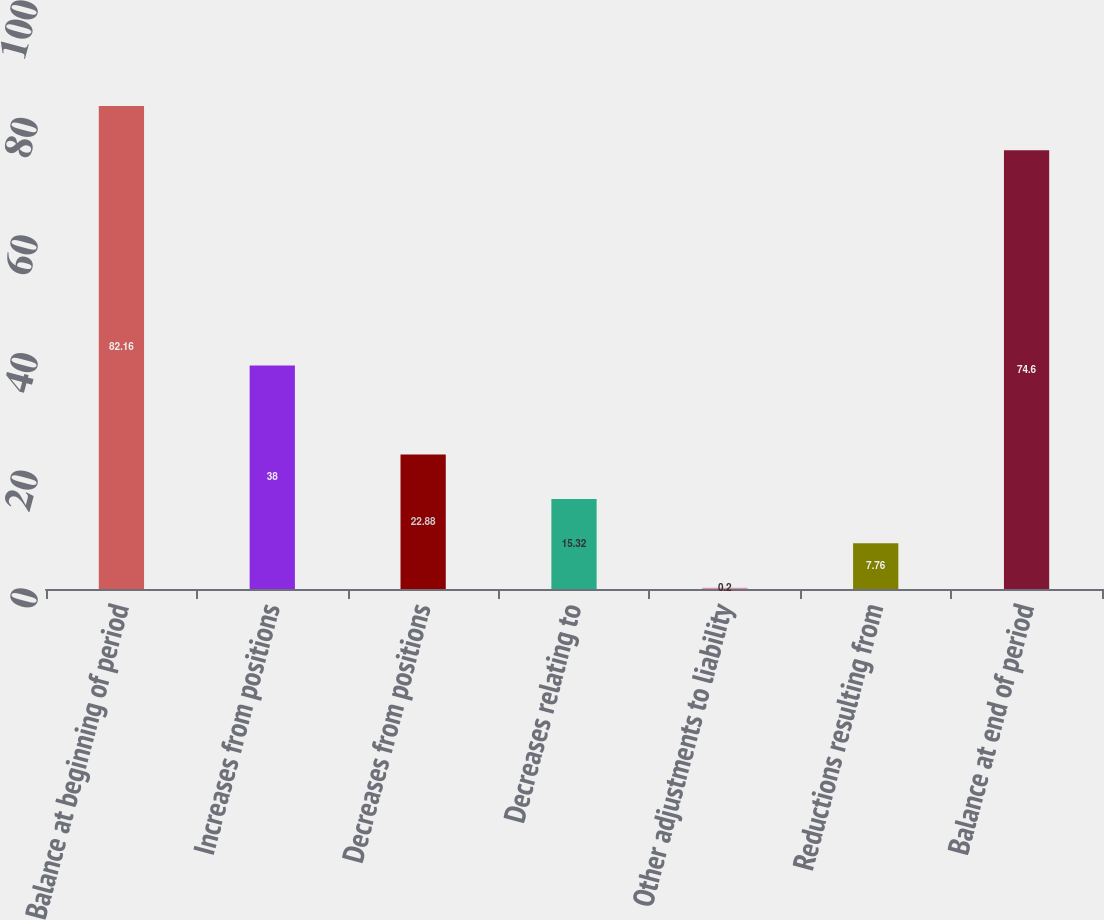Convert chart to OTSL. <chart><loc_0><loc_0><loc_500><loc_500><bar_chart><fcel>Balance at beginning of period<fcel>Increases from positions<fcel>Decreases from positions<fcel>Decreases relating to<fcel>Other adjustments to liability<fcel>Reductions resulting from<fcel>Balance at end of period<nl><fcel>82.16<fcel>38<fcel>22.88<fcel>15.32<fcel>0.2<fcel>7.76<fcel>74.6<nl></chart> 